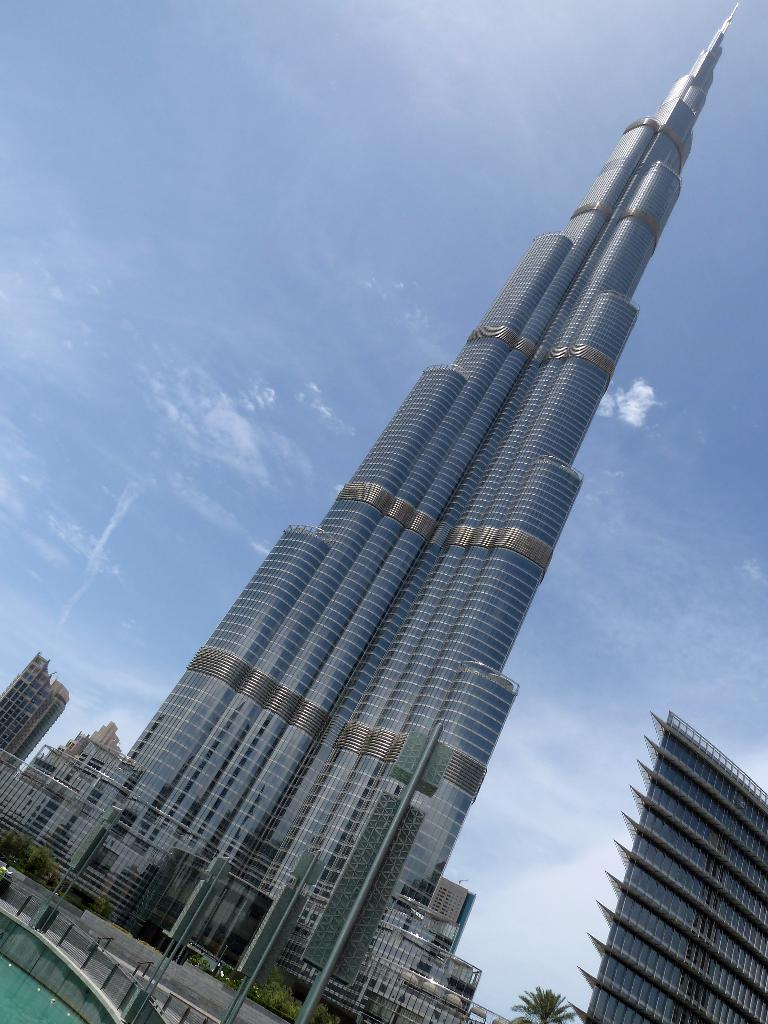What type of structures can be seen in the image? There are buildings in the image. What natural element is present in the image? There is a tree in the image. What type of vegetation can be seen in the image? There are plants in the image. What can be seen flowing or standing still in the image? There is water visible in the image. What part of the natural environment is visible in the image? The sky is visible in the image. What theory is being debated by the buildings in the image? There is no indication in the image that the buildings are debating any theories. Can you describe the fight between the tree and the plants in the image? There is no fight between the tree and the plants in the image; they are both stationary and not engaged in any conflict. 